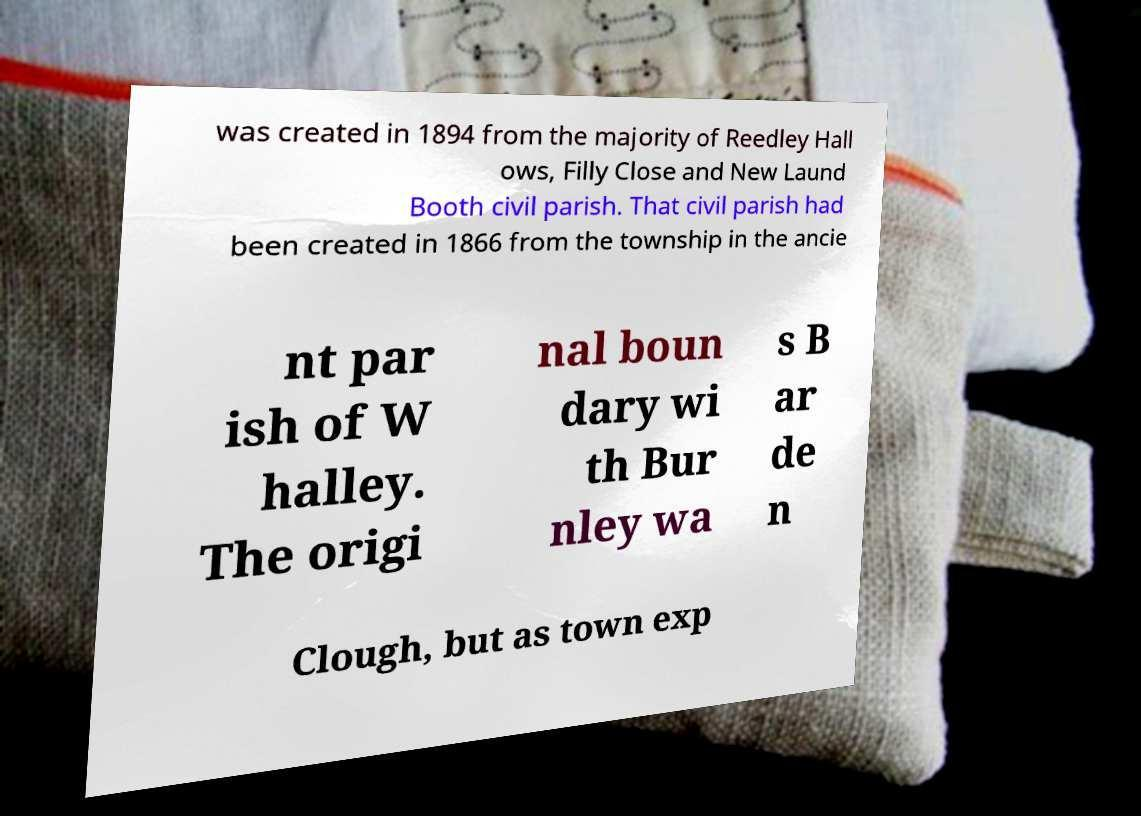Could you extract and type out the text from this image? was created in 1894 from the majority of Reedley Hall ows, Filly Close and New Laund Booth civil parish. That civil parish had been created in 1866 from the township in the ancie nt par ish of W halley. The origi nal boun dary wi th Bur nley wa s B ar de n Clough, but as town exp 